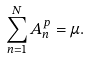<formula> <loc_0><loc_0><loc_500><loc_500>\sum ^ { N } _ { n = 1 } A ^ { p } _ { n } = \mu .</formula> 